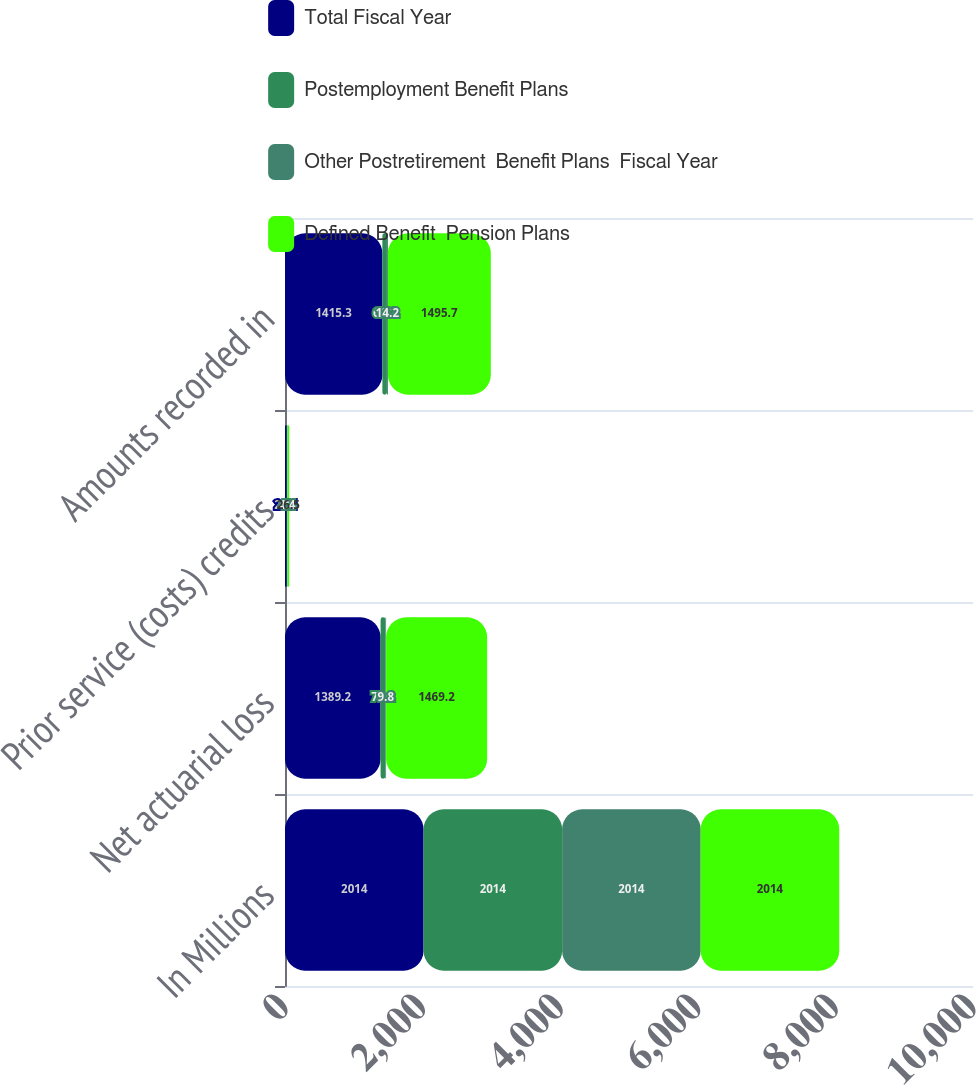<chart> <loc_0><loc_0><loc_500><loc_500><stacked_bar_chart><ecel><fcel>In Millions<fcel>Net actuarial loss<fcel>Prior service (costs) credits<fcel>Amounts recorded in<nl><fcel>Total Fiscal Year<fcel>2014<fcel>1389.2<fcel>26.1<fcel>1415.3<nl><fcel>Postemployment Benefit Plans<fcel>2014<fcel>70.2<fcel>4<fcel>66.2<nl><fcel>Other Postretirement  Benefit Plans  Fiscal Year<fcel>2014<fcel>9.8<fcel>4.4<fcel>14.2<nl><fcel>Defined Benefit  Pension Plans<fcel>2014<fcel>1469.2<fcel>26.5<fcel>1495.7<nl></chart> 